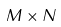<formula> <loc_0><loc_0><loc_500><loc_500>M \times N</formula> 